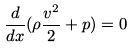<formula> <loc_0><loc_0><loc_500><loc_500>\frac { d } { d x } ( \rho \frac { v ^ { 2 } } { 2 } + p ) = 0</formula> 